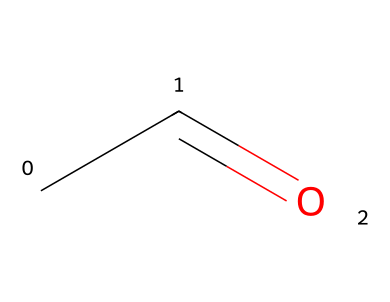What is the name of this chemical? The SMILES representation "CC=O" corresponds to acetaldehyde, which is a common aldehyde. The "C" represents carbon atoms, and "C=O" indicates a carbonyl group (the aldehyde functional group). Therefore, the name can be derived directly from this structure.
Answer: acetaldehyde How many carbon atoms are in this molecule? The SMILES "CC=O" shows that there are two "C" atoms. Each "C" corresponds to a carbon atom in the chemical structure, providing a total count.
Answer: 2 What functional group is present in this compound? The structure contains the carbonyl group (=O) attached to the terminal carbon atom, characteristic of aldehydes. The presence of this specific functional group defines it as an aldehyde.
Answer: aldehyde What is the molecular formula for acetaldehyde? By analyzing the SMILES "CC=O," we see it contains 2 carbon atoms (C), 4 hydrogen atoms (H), and 1 oxygen atom (O). The molecular formula is thus derived from this count.
Answer: C2H4O Is this molecule polar or nonpolar? Acetaldehyde has a polar functional group (the carbonyl) and exhibits polarity due to the difference in electronegativity between carbon and oxygen. Therefore, we conclude its overall polarity is due to the presence of the carbonyl group.
Answer: polar How many total valence electrons does acetaldehyde have? For acetaldehyde (C2H4O), we count the valence electrons: each C has 4 (2 C), each H has 1 (4 H), and O has 6. Adding these gives us a total of 14 valence electrons for the molecule.
Answer: 14 What type of isomerism can acetaldehyde exhibit? Acetaldehyde may show structural isomerism due to the arrangement of its atoms while maintaining the same molecular formula. The possibility arises from different connections of the same atoms in the structure.
Answer: structural isomerism 